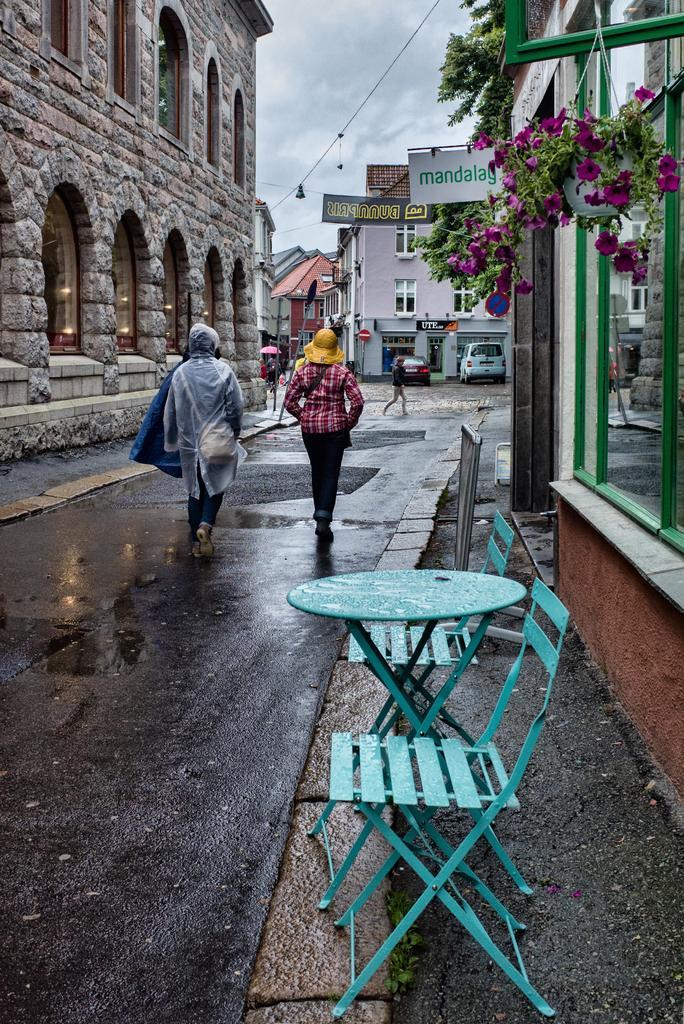Please provide a concise description of this image. In this image we can see some persons wearing sweaters and caps walking in the street, at the foreground of the image there are some chairs, table, at the right side of the image there are some plants, flowers and at the left side of the image there is house and at the background of the image there are some houses and clear sky. 